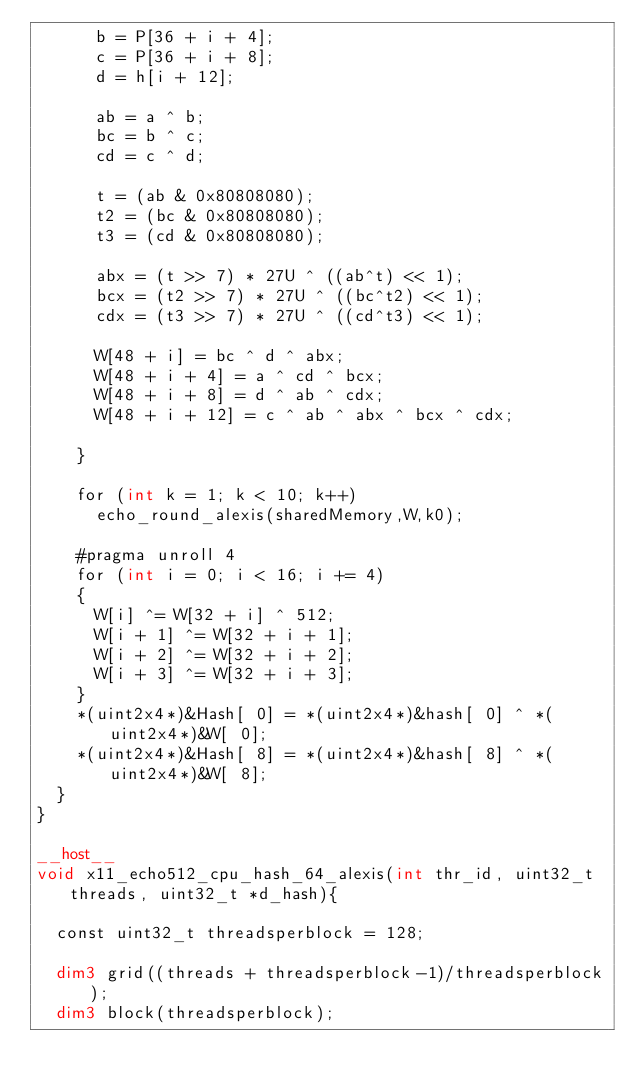Convert code to text. <code><loc_0><loc_0><loc_500><loc_500><_Cuda_>			b = P[36 + i + 4];
			c = P[36 + i + 8];
			d = h[i + 12];

			ab = a ^ b;
			bc = b ^ c;
			cd = c ^ d;

			t = (ab & 0x80808080);
			t2 = (bc & 0x80808080);
			t3 = (cd & 0x80808080);

			abx = (t >> 7) * 27U ^ ((ab^t) << 1);
			bcx = (t2 >> 7) * 27U ^ ((bc^t2) << 1);
			cdx = (t3 >> 7) * 27U ^ ((cd^t3) << 1);

			W[48 + i] = bc ^ d ^ abx;
			W[48 + i + 4] = a ^ cd ^ bcx;
			W[48 + i + 8] = d ^ ab ^ cdx;
			W[48 + i + 12] = c ^ ab ^ abx ^ bcx ^ cdx;

		}

		for (int k = 1; k < 10; k++)
			echo_round_alexis(sharedMemory,W,k0);

		#pragma unroll 4
		for (int i = 0; i < 16; i += 4)
		{
			W[i] ^= W[32 + i] ^ 512;
			W[i + 1] ^= W[32 + i + 1];
			W[i + 2] ^= W[32 + i + 2];
			W[i + 3] ^= W[32 + i + 3];
		}
		*(uint2x4*)&Hash[ 0] = *(uint2x4*)&hash[ 0] ^ *(uint2x4*)&W[ 0];
		*(uint2x4*)&Hash[ 8] = *(uint2x4*)&hash[ 8] ^ *(uint2x4*)&W[ 8];
	}
}

__host__
void x11_echo512_cpu_hash_64_alexis(int thr_id, uint32_t threads, uint32_t *d_hash){

	const uint32_t threadsperblock = 128;

	dim3 grid((threads + threadsperblock-1)/threadsperblock);
	dim3 block(threadsperblock);
</code> 